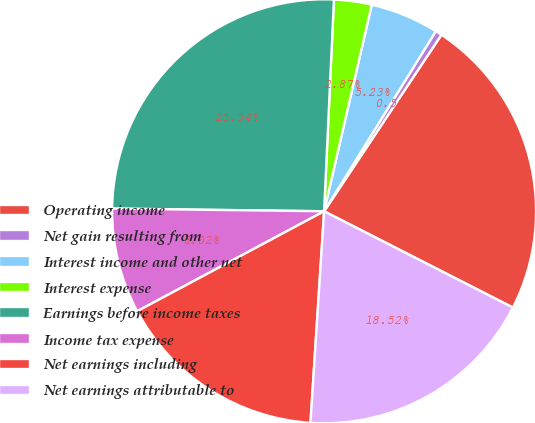Convert chart to OTSL. <chart><loc_0><loc_0><loc_500><loc_500><pie_chart><fcel>Operating income<fcel>Net gain resulting from<fcel>Interest income and other net<fcel>Interest expense<fcel>Earnings before income taxes<fcel>Income tax expense<fcel>Net earnings including<fcel>Net earnings attributable to<nl><fcel>23.17%<fcel>0.5%<fcel>5.23%<fcel>2.87%<fcel>25.54%<fcel>8.02%<fcel>16.16%<fcel>18.52%<nl></chart> 